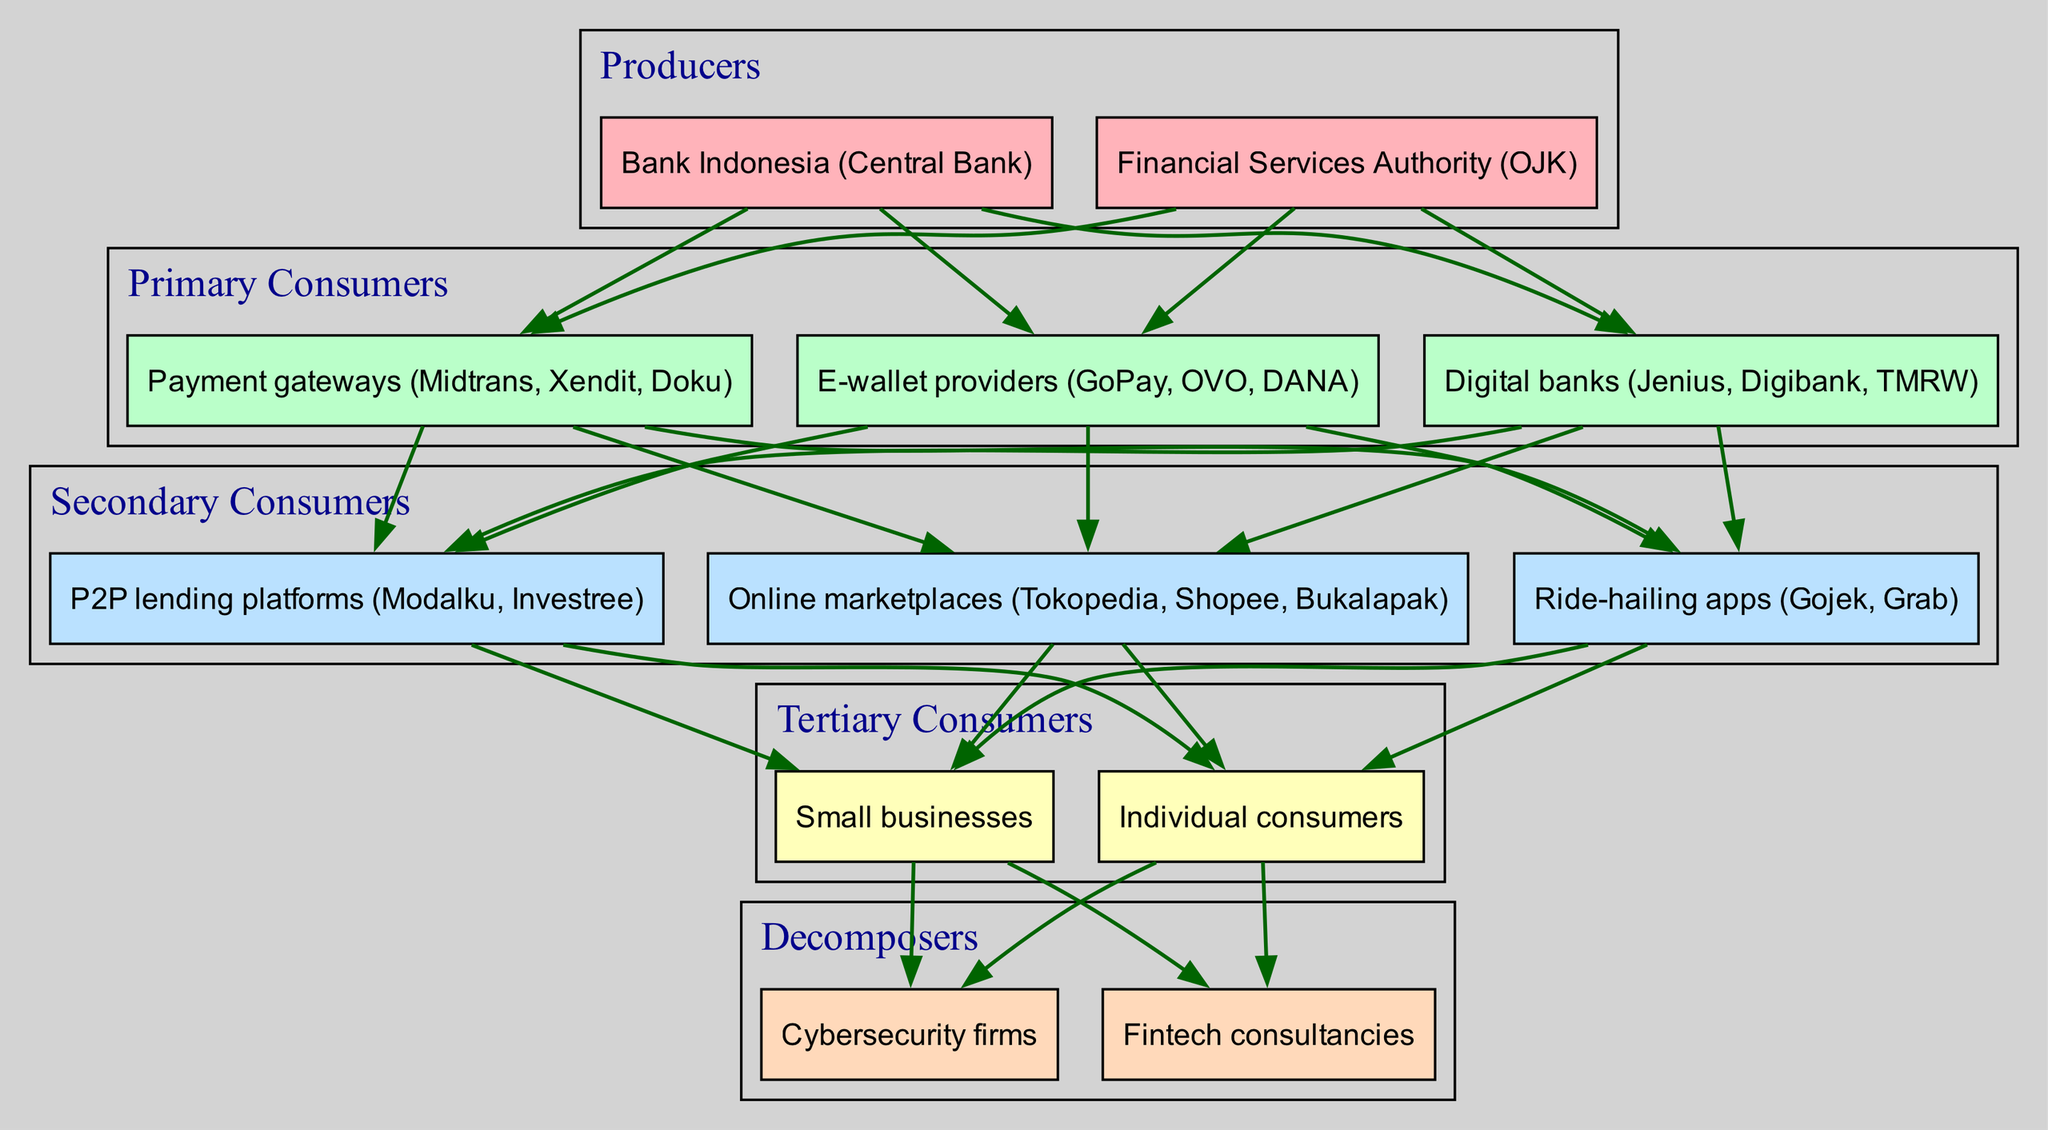What are the producers in the diagram? The producers are located at the top of the food chain in the diagram. They include the organizations that initiate the flow of digital payment systems in Indonesia. Identifying these nodes provides the relevant answer.
Answer: Bank Indonesia, Financial Services Authority How many primary consumers are there? To find the number of primary consumers, I count the distinct entities present in the primary consumers' section of the diagram. There are three entities listed.
Answer: 3 Which entities are connected directly to online marketplaces? Online marketplaces are at the secondary consumer level. By examining the edges connecting to it, the entities in the preceding level can be identified. Payment gateways, digital banks, and e-wallet providers connect directly to online marketplaces.
Answer: Payment gateways, digital banks, e-wallet providers What is the relationship between e-wallet providers and individual consumers? To determine the relationship, I trace the connections: e-wallet providers are linked to online marketplaces in the secondary consumer section, which then connects to individual consumers in the tertiary consumers' section. This signifies a flow of payment processing from e-wallet providers to individual consumers through online platforms.
Answer: Flow of payments How many decomposer entities are identified in the diagram? Decomposers are located at the bottom section of the food chain. I count the distinct entities listed under the decomposers' section to arrive at the answer. There are two entities mentioned.
Answer: 2 What is the color used to represent primary consumers in the diagram? Each level of the food chain is assigned a specific color to enhance visualization. By examining the color scheme specified in the diagram for primary consumers, I identify the corresponding color.
Answer: Light green Which consumer category connects directly to small businesses? Small businesses are included under tertiary consumers. By reviewing the connections, I find that the preceding category of secondary consumers connects to them. Therefore, this helps clarify which consumer category is linked to small businesses.
Answer: Secondary consumers What is the primary role of cybersecurity firms according to the diagram? Cybersecurity firms are categorized as decomposers, which means their role is to support the ecosystem by ensuring the security of transactions and data within the fintech ecosystem, serving as a critical support service. This understanding stems from their placement at the end of the flow.
Answer: Support security How many entities fall under the tertiary consumers section? To answer this, I look at the tertiary consumers' section in the diagram and count the listed entities. There are two entities represented here.
Answer: 2 